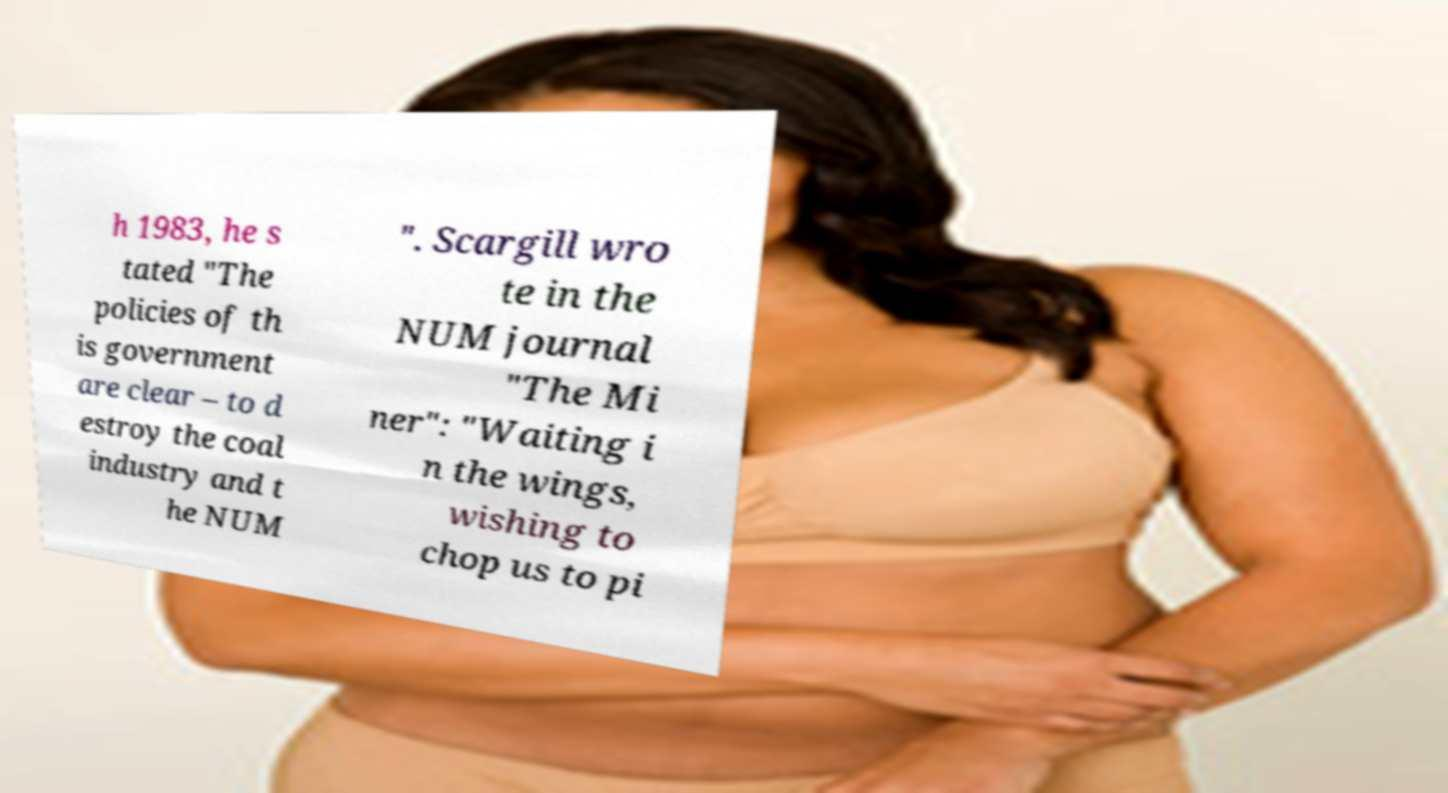Could you extract and type out the text from this image? h 1983, he s tated "The policies of th is government are clear – to d estroy the coal industry and t he NUM ". Scargill wro te in the NUM journal "The Mi ner": "Waiting i n the wings, wishing to chop us to pi 